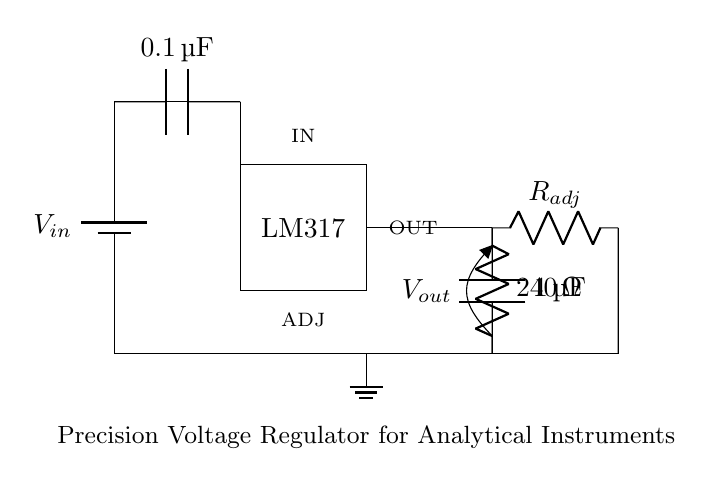What is the input capacitor value? The input capacitor is labeled as 0.1 microfarad, which provides stability to the voltage regulator.
Answer: 0.1 microfarad What component is used as the voltage regulator? The circuit diagram indicates that an LM317 is used as the voltage regulator, which is a popular integrated circuit for this purpose.
Answer: LM317 What is the resistance value of R_adj? The diagram does not specify a numeric value for R_adj, but it is typically a variable resistor that adjusts the output voltage in LM317 circuits.
Answer: Not specified What is the output capacitor value? The output capacitor is labeled as 1 microfarad, which helps smoothen the output voltage and improve transient response.
Answer: 1 microfarad What role does the input capacitor play in this circuit? The input capacitor is connected to the input of the LM317, providing filtering to reduce voltage spikes and ensuring stable input voltage.
Answer: Filtering What is the output voltage of the circuit? The output voltage is not directly stated, but it suggests adjustable output depending on the configured R_adj resistor through the LM317.
Answer: Adjustable What does R_adj influence in this circuit? R_adj directly regulates the output voltage of the LM317 by determining the feedback provided to the regulator, thereby setting the output voltage level.
Answer: Output voltage 